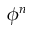Convert formula to latex. <formula><loc_0><loc_0><loc_500><loc_500>\phi ^ { n }</formula> 